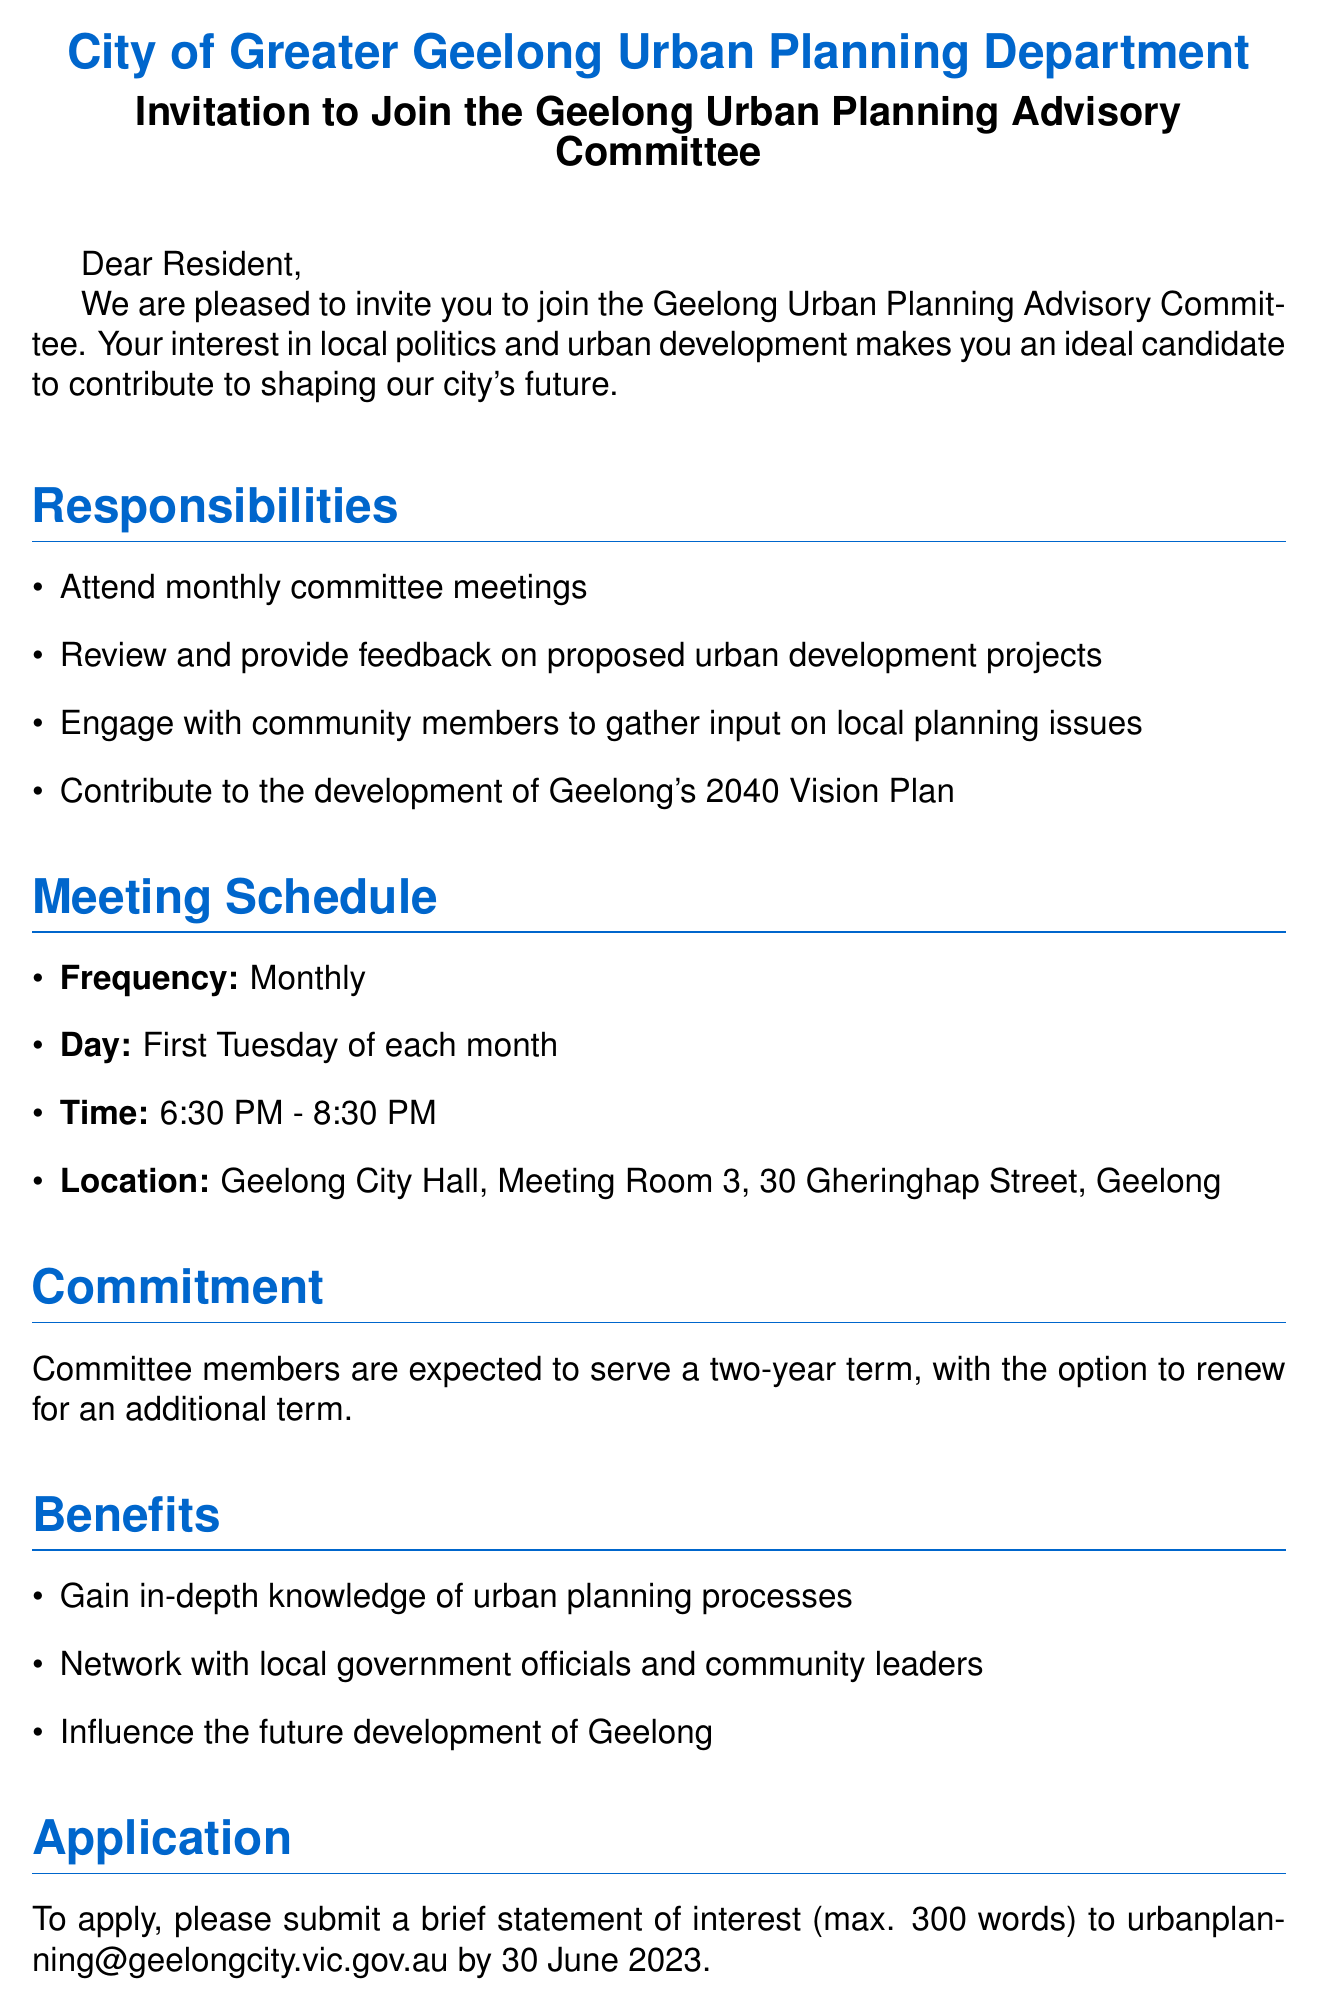What is the name of the committee? The name of the committee is stated in the document.
Answer: Geelong Urban Planning Advisory Committee What is the meeting frequency? The frequency of the meetings is mentioned in the meeting schedule section.
Answer: Monthly When are the meetings held? The document specifies the day of the meetings.
Answer: First Tuesday of each month What is the location of the meetings? The location is provided in the meeting schedule section.
Answer: Geelong City Hall, Meeting Room 3, 30 Gheringhap Street, Geelong How long is the committee term? The document states the duration of commitment for committee members.
Answer: Two-year term What is the contact person's name? The document provides the name of the contact person for more information.
Answer: Sarah Thompson What is the application deadline? The deadline for application submission is mentioned in the application section.
Answer: 30 June 2023 What is one benefit of joining the committee? A benefit of joining is listed in the benefits section of the document.
Answer: Gain in-depth knowledge of urban planning processes How many members are expected to be present at the meetings? The document mentions the expected attendance but does not specify a number; rather it indicates members need to attend.
Answer: Attend monthly committee meetings 